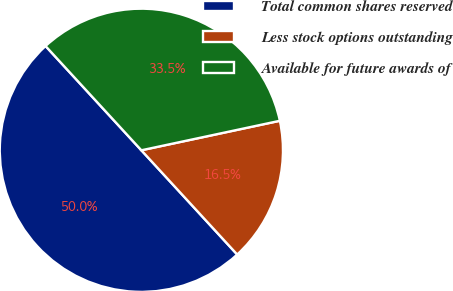Convert chart. <chart><loc_0><loc_0><loc_500><loc_500><pie_chart><fcel>Total common shares reserved<fcel>Less stock options outstanding<fcel>Available for future awards of<nl><fcel>50.0%<fcel>16.51%<fcel>33.49%<nl></chart> 